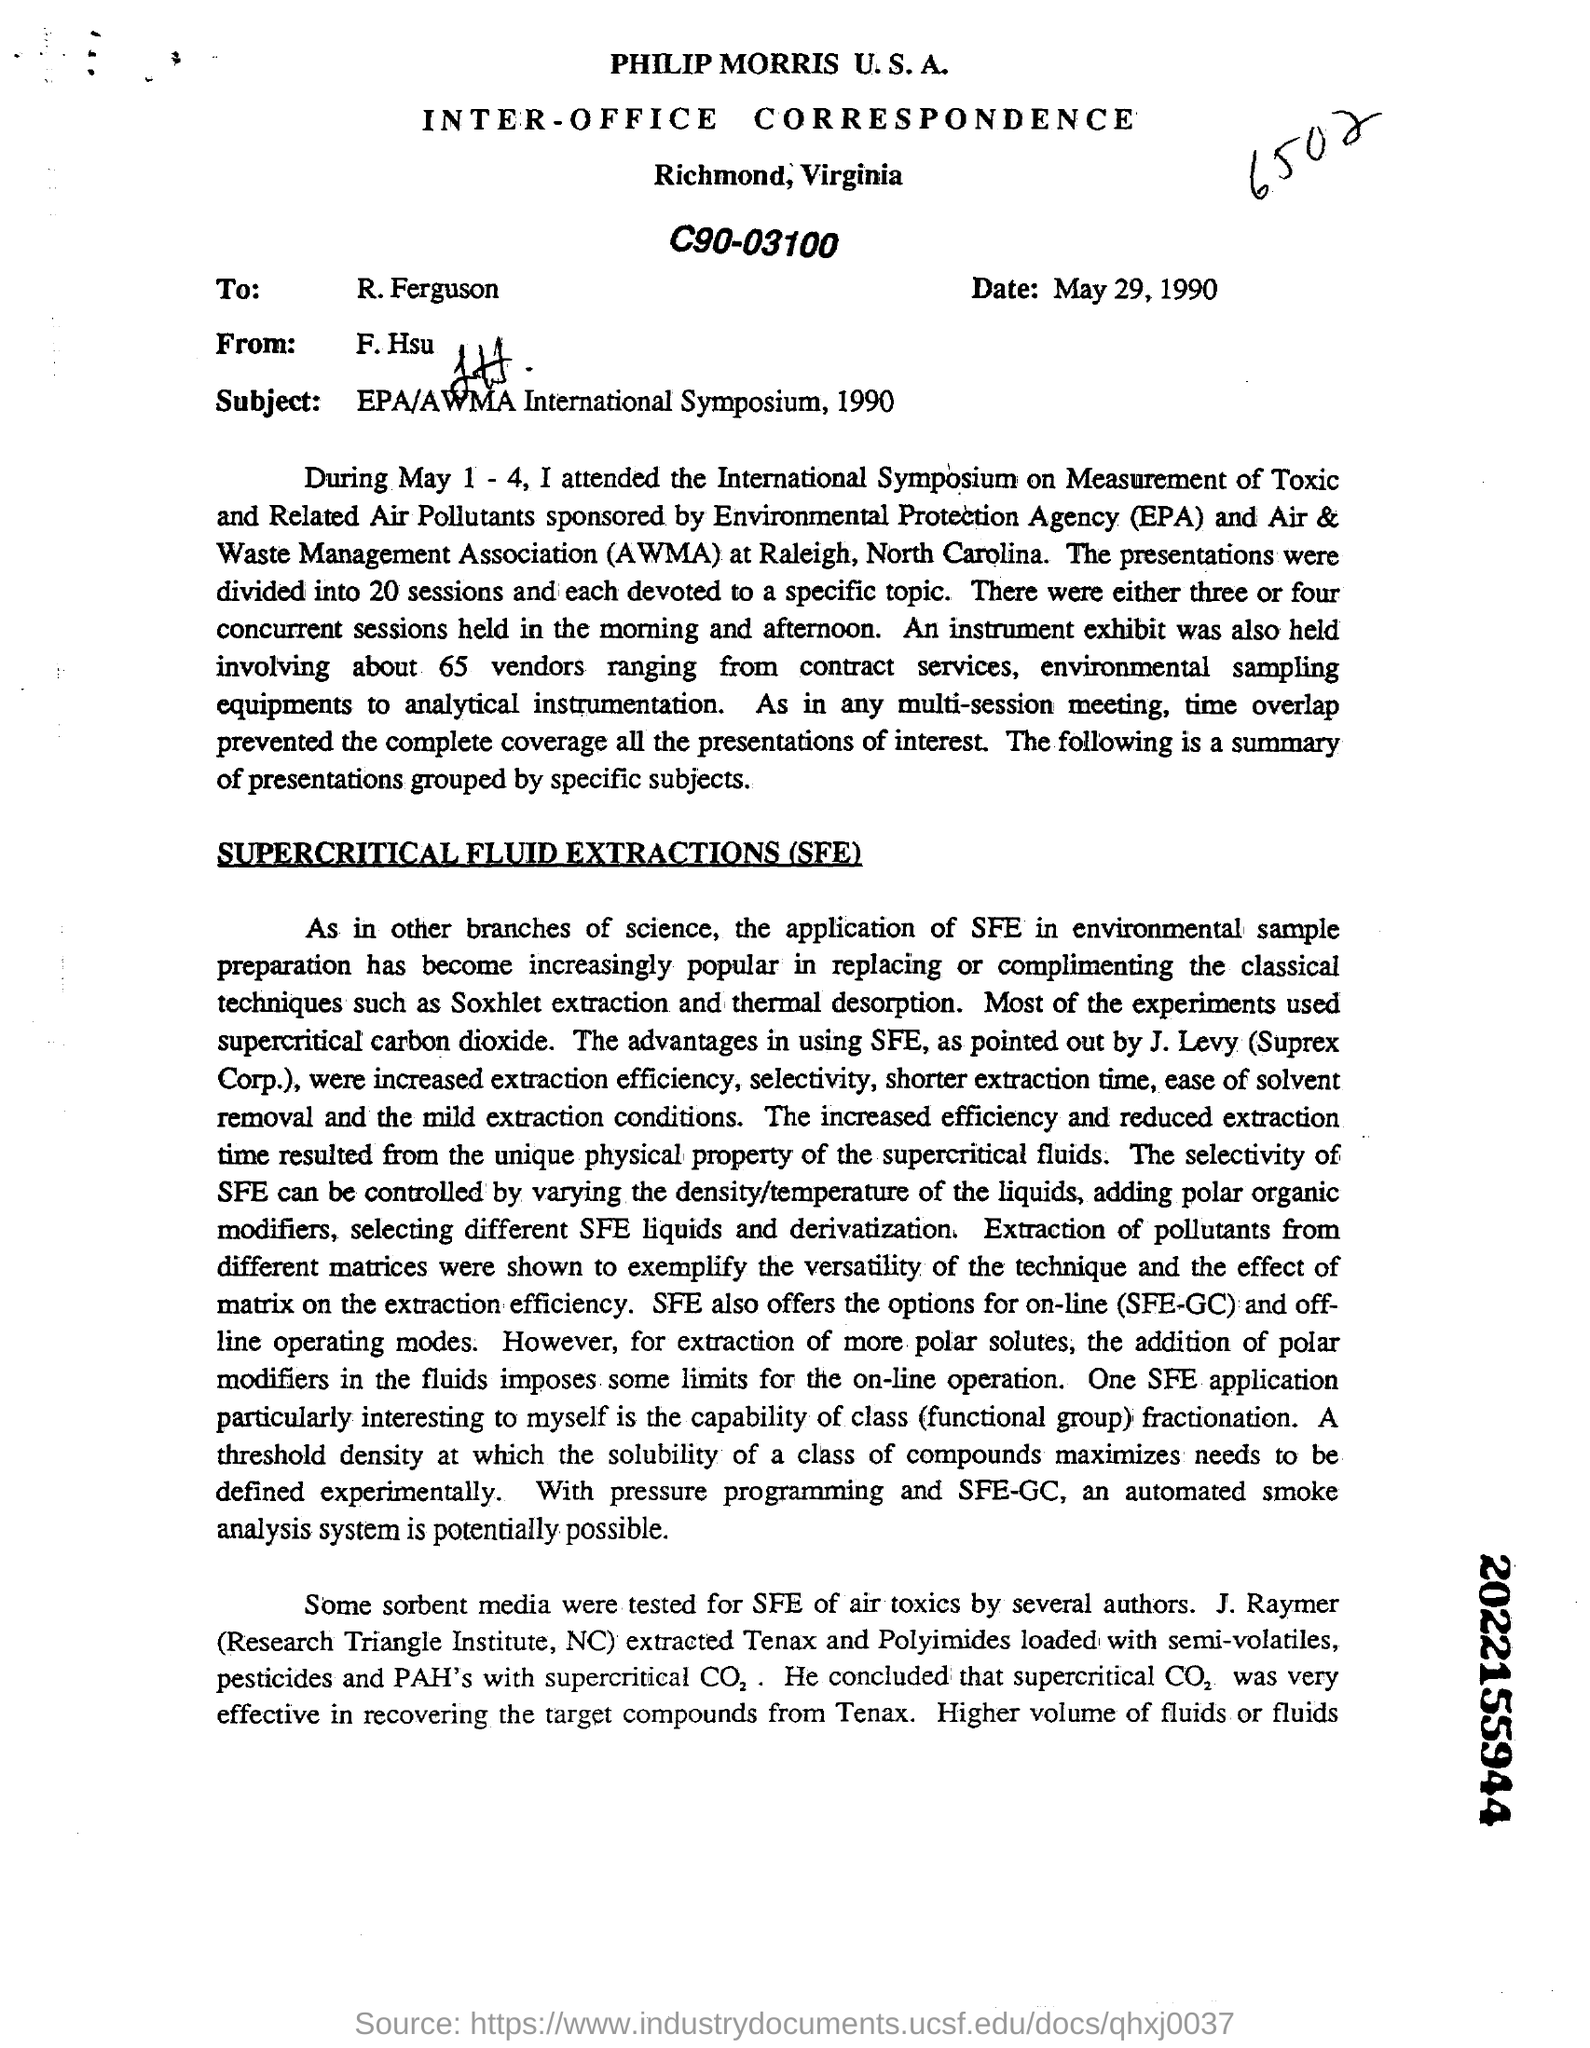What is the date mentioned?
Your answer should be compact. May 29, 1990. To whom is this letter addressed?
Your answer should be very brief. R.Ferguson. What is the subject of the document?
Provide a short and direct response. EPA/AWMA International Symposium, 1990. What is the 10 digits number mentioned in bold on the right margin, at the bottom?
Your answer should be compact. 2022155944. 